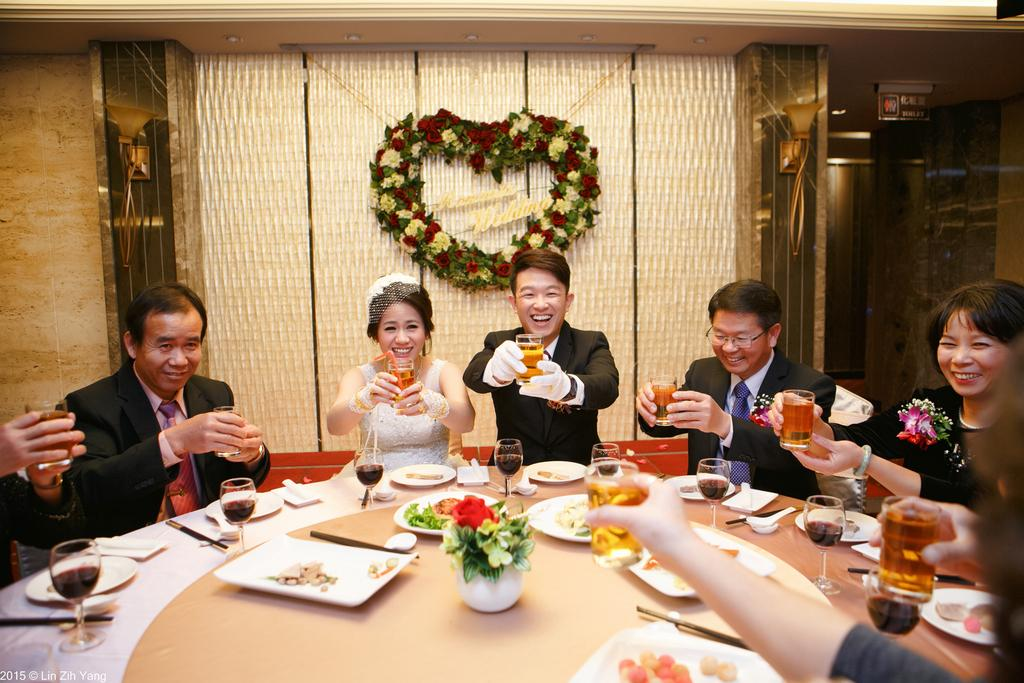Who is present in the image? There are people in the image. What are the people doing in the image? The people are sitting. What are the people holding in the image? The people are holding wine glasses. What is on the table in the image? There is a table in the image, and there are trays on the table. What is on the trays on the table? There are food items on the trays. What type of toothpaste is visible on the table in the image? There is no toothpaste present in the image. What toys are the people playing with in the image? There are no toys present in the image. 